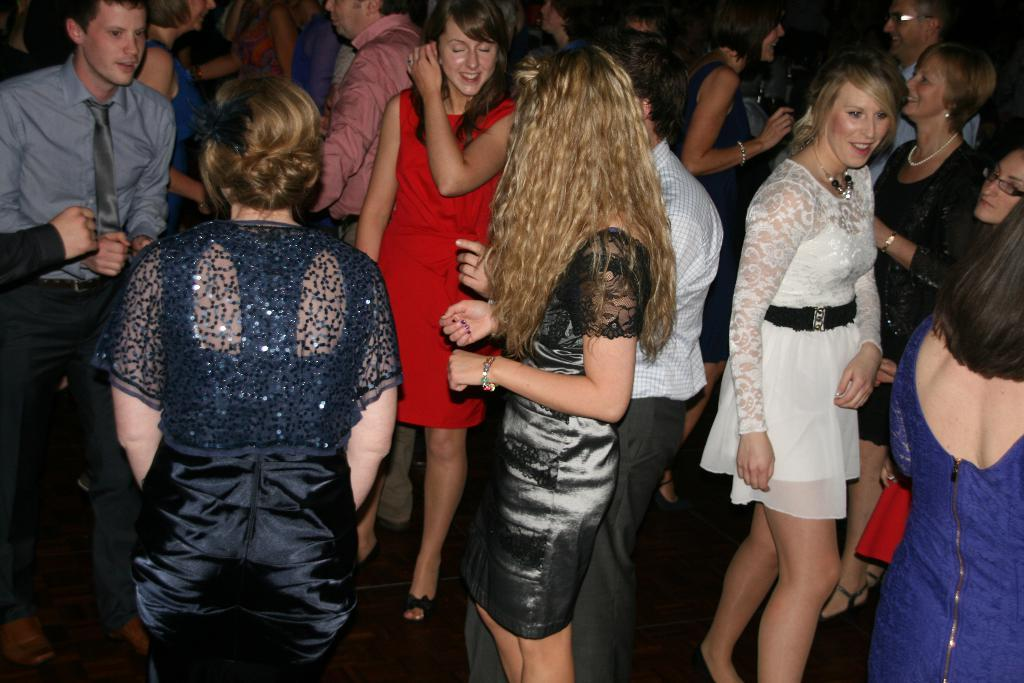How many people are in the image? There is a group of people in the image. What are some of the people doing in the image? Some of the people are standing on the floor, and some of them are smiling. What can be observed about the lighting in the image? The background of the image is dark. How does the group of people increase their knowledge in the image? There is no indication in the image that the group of people is increasing their knowledge. 